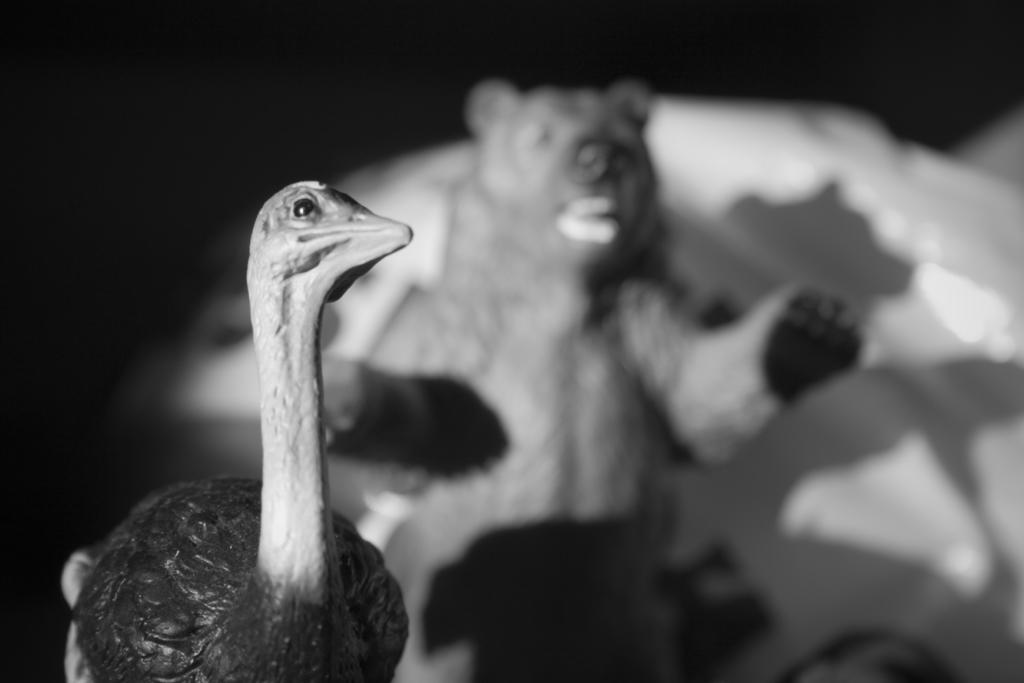What is the color scheme of the image? The image is black and white. What is the main subject in the center of the image? There is a bird in the center of the image. What type of animal is in the center of the image? There is an animal in the center of the image. What is the goat protesting about in the image? There is no goat present in the image, and therefore no protest can be observed. 